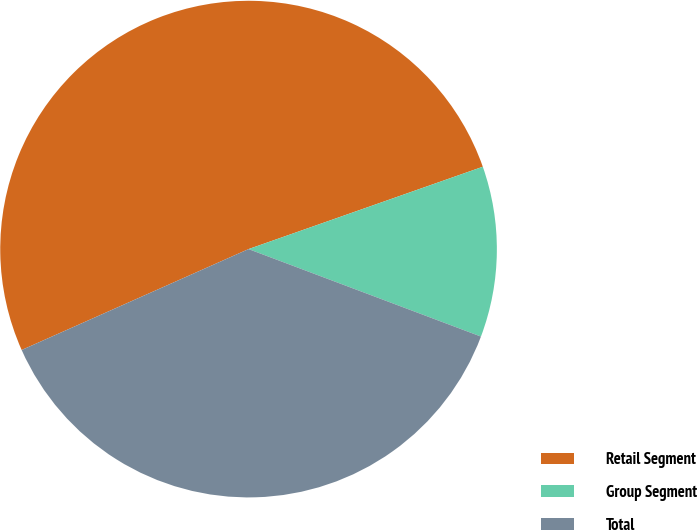Convert chart to OTSL. <chart><loc_0><loc_0><loc_500><loc_500><pie_chart><fcel>Retail Segment<fcel>Group Segment<fcel>Total<nl><fcel>51.28%<fcel>11.11%<fcel>37.61%<nl></chart> 